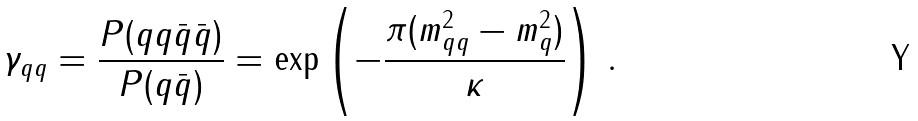<formula> <loc_0><loc_0><loc_500><loc_500>\gamma _ { q q } = \frac { P ( q q \bar { q } \bar { q } ) } { P ( q \bar { q } ) } = \exp \left ( - \frac { \pi ( m _ { q q } ^ { 2 } - m _ { q } ^ { 2 } ) } { \kappa } \right ) \, .</formula> 